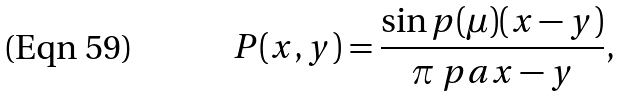<formula> <loc_0><loc_0><loc_500><loc_500>P ( x , y ) = \frac { \sin p ( \mu ) ( x - y ) } { \pi \ p a { x - y } } ,</formula> 